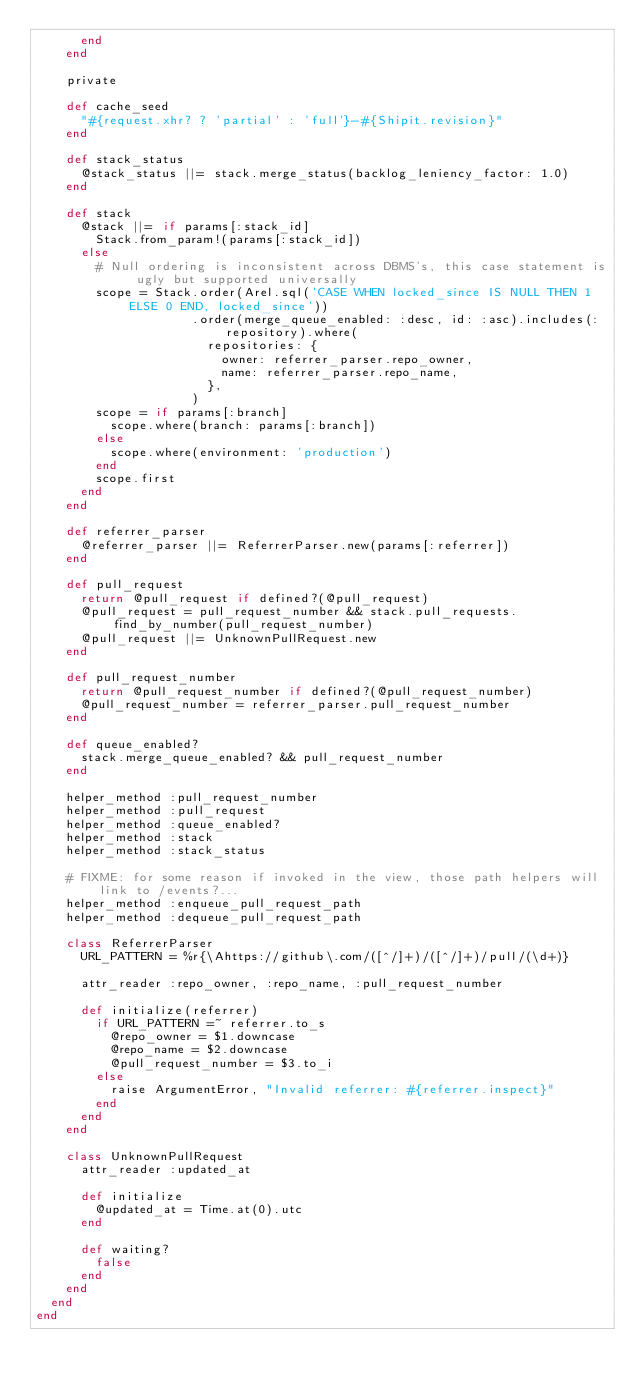Convert code to text. <code><loc_0><loc_0><loc_500><loc_500><_Ruby_>      end
    end

    private

    def cache_seed
      "#{request.xhr? ? 'partial' : 'full'}-#{Shipit.revision}"
    end

    def stack_status
      @stack_status ||= stack.merge_status(backlog_leniency_factor: 1.0)
    end

    def stack
      @stack ||= if params[:stack_id]
        Stack.from_param!(params[:stack_id])
      else
        # Null ordering is inconsistent across DBMS's, this case statement is ugly but supported universally
        scope = Stack.order(Arel.sql('CASE WHEN locked_since IS NULL THEN 1 ELSE 0 END, locked_since'))
                     .order(merge_queue_enabled: :desc, id: :asc).includes(:repository).where(
                       repositories: {
                         owner: referrer_parser.repo_owner,
                         name: referrer_parser.repo_name,
                       },
                     )
        scope = if params[:branch]
          scope.where(branch: params[:branch])
        else
          scope.where(environment: 'production')
        end
        scope.first
      end
    end

    def referrer_parser
      @referrer_parser ||= ReferrerParser.new(params[:referrer])
    end

    def pull_request
      return @pull_request if defined?(@pull_request)
      @pull_request = pull_request_number && stack.pull_requests.find_by_number(pull_request_number)
      @pull_request ||= UnknownPullRequest.new
    end

    def pull_request_number
      return @pull_request_number if defined?(@pull_request_number)
      @pull_request_number = referrer_parser.pull_request_number
    end

    def queue_enabled?
      stack.merge_queue_enabled? && pull_request_number
    end

    helper_method :pull_request_number
    helper_method :pull_request
    helper_method :queue_enabled?
    helper_method :stack
    helper_method :stack_status

    # FIXME: for some reason if invoked in the view, those path helpers will link to /events?...
    helper_method :enqueue_pull_request_path
    helper_method :dequeue_pull_request_path

    class ReferrerParser
      URL_PATTERN = %r{\Ahttps://github\.com/([^/]+)/([^/]+)/pull/(\d+)}

      attr_reader :repo_owner, :repo_name, :pull_request_number

      def initialize(referrer)
        if URL_PATTERN =~ referrer.to_s
          @repo_owner = $1.downcase
          @repo_name = $2.downcase
          @pull_request_number = $3.to_i
        else
          raise ArgumentError, "Invalid referrer: #{referrer.inspect}"
        end
      end
    end

    class UnknownPullRequest
      attr_reader :updated_at

      def initialize
        @updated_at = Time.at(0).utc
      end

      def waiting?
        false
      end
    end
  end
end
</code> 